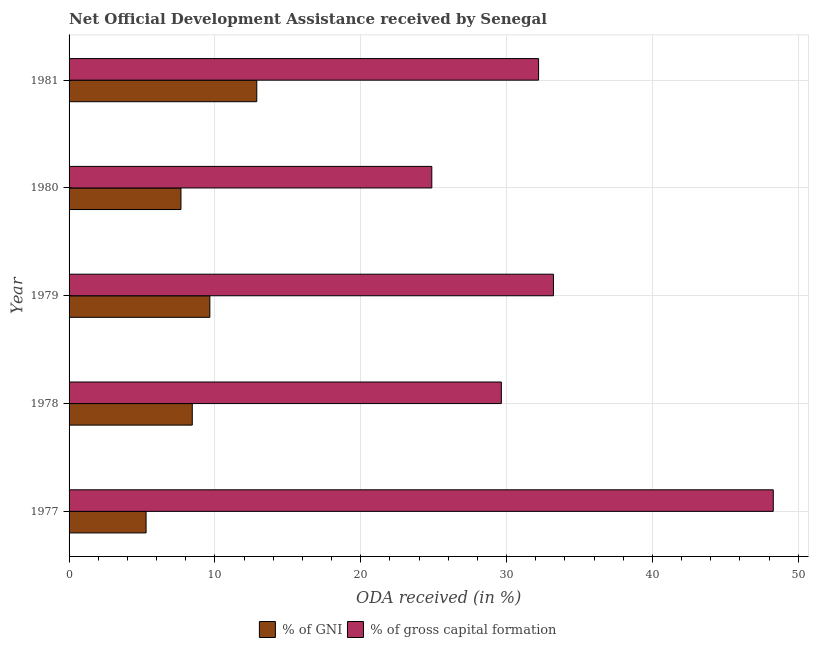How many different coloured bars are there?
Your answer should be compact. 2. Are the number of bars per tick equal to the number of legend labels?
Provide a short and direct response. Yes. Are the number of bars on each tick of the Y-axis equal?
Offer a very short reply. Yes. How many bars are there on the 1st tick from the top?
Your response must be concise. 2. What is the label of the 4th group of bars from the top?
Your answer should be very brief. 1978. What is the oda received as percentage of gni in 1978?
Your response must be concise. 8.45. Across all years, what is the maximum oda received as percentage of gni?
Your answer should be compact. 12.87. Across all years, what is the minimum oda received as percentage of gross capital formation?
Offer a very short reply. 24.87. What is the total oda received as percentage of gni in the graph?
Offer a terse response. 43.93. What is the difference between the oda received as percentage of gross capital formation in 1977 and that in 1981?
Ensure brevity in your answer.  16.09. What is the difference between the oda received as percentage of gross capital formation in 1981 and the oda received as percentage of gni in 1978?
Give a very brief answer. 23.75. What is the average oda received as percentage of gross capital formation per year?
Provide a short and direct response. 33.65. In the year 1979, what is the difference between the oda received as percentage of gross capital formation and oda received as percentage of gni?
Offer a very short reply. 23.56. What is the ratio of the oda received as percentage of gni in 1979 to that in 1980?
Keep it short and to the point. 1.26. What is the difference between the highest and the second highest oda received as percentage of gni?
Provide a succinct answer. 3.22. What is the difference between the highest and the lowest oda received as percentage of gni?
Provide a short and direct response. 7.59. What does the 2nd bar from the top in 1981 represents?
Provide a succinct answer. % of GNI. What does the 2nd bar from the bottom in 1978 represents?
Keep it short and to the point. % of gross capital formation. What is the difference between two consecutive major ticks on the X-axis?
Ensure brevity in your answer.  10. Are the values on the major ticks of X-axis written in scientific E-notation?
Your response must be concise. No. Does the graph contain any zero values?
Your response must be concise. No. Where does the legend appear in the graph?
Offer a very short reply. Bottom center. How are the legend labels stacked?
Your answer should be very brief. Horizontal. What is the title of the graph?
Your answer should be very brief. Net Official Development Assistance received by Senegal. Does "Nonresident" appear as one of the legend labels in the graph?
Your answer should be very brief. No. What is the label or title of the X-axis?
Your answer should be very brief. ODA received (in %). What is the label or title of the Y-axis?
Offer a terse response. Year. What is the ODA received (in %) in % of GNI in 1977?
Your answer should be compact. 5.28. What is the ODA received (in %) in % of gross capital formation in 1977?
Provide a succinct answer. 48.29. What is the ODA received (in %) in % of GNI in 1978?
Make the answer very short. 8.45. What is the ODA received (in %) in % of gross capital formation in 1978?
Give a very brief answer. 29.64. What is the ODA received (in %) in % of GNI in 1979?
Make the answer very short. 9.65. What is the ODA received (in %) of % of gross capital formation in 1979?
Ensure brevity in your answer.  33.22. What is the ODA received (in %) of % of GNI in 1980?
Ensure brevity in your answer.  7.67. What is the ODA received (in %) of % of gross capital formation in 1980?
Give a very brief answer. 24.87. What is the ODA received (in %) in % of GNI in 1981?
Your response must be concise. 12.87. What is the ODA received (in %) in % of gross capital formation in 1981?
Offer a very short reply. 32.2. Across all years, what is the maximum ODA received (in %) in % of GNI?
Provide a short and direct response. 12.87. Across all years, what is the maximum ODA received (in %) in % of gross capital formation?
Ensure brevity in your answer.  48.29. Across all years, what is the minimum ODA received (in %) of % of GNI?
Your response must be concise. 5.28. Across all years, what is the minimum ODA received (in %) of % of gross capital formation?
Offer a very short reply. 24.87. What is the total ODA received (in %) in % of GNI in the graph?
Your response must be concise. 43.93. What is the total ODA received (in %) in % of gross capital formation in the graph?
Provide a short and direct response. 168.22. What is the difference between the ODA received (in %) of % of GNI in 1977 and that in 1978?
Ensure brevity in your answer.  -3.17. What is the difference between the ODA received (in %) in % of gross capital formation in 1977 and that in 1978?
Ensure brevity in your answer.  18.65. What is the difference between the ODA received (in %) in % of GNI in 1977 and that in 1979?
Your answer should be very brief. -4.37. What is the difference between the ODA received (in %) in % of gross capital formation in 1977 and that in 1979?
Provide a short and direct response. 15.07. What is the difference between the ODA received (in %) in % of GNI in 1977 and that in 1980?
Provide a short and direct response. -2.39. What is the difference between the ODA received (in %) of % of gross capital formation in 1977 and that in 1980?
Give a very brief answer. 23.42. What is the difference between the ODA received (in %) of % of GNI in 1977 and that in 1981?
Make the answer very short. -7.59. What is the difference between the ODA received (in %) in % of gross capital formation in 1977 and that in 1981?
Keep it short and to the point. 16.1. What is the difference between the ODA received (in %) of % of GNI in 1978 and that in 1979?
Your answer should be very brief. -1.21. What is the difference between the ODA received (in %) in % of gross capital formation in 1978 and that in 1979?
Ensure brevity in your answer.  -3.57. What is the difference between the ODA received (in %) of % of GNI in 1978 and that in 1980?
Provide a succinct answer. 0.78. What is the difference between the ODA received (in %) in % of gross capital formation in 1978 and that in 1980?
Your answer should be very brief. 4.77. What is the difference between the ODA received (in %) of % of GNI in 1978 and that in 1981?
Offer a terse response. -4.42. What is the difference between the ODA received (in %) in % of gross capital formation in 1978 and that in 1981?
Your answer should be compact. -2.55. What is the difference between the ODA received (in %) in % of GNI in 1979 and that in 1980?
Offer a very short reply. 1.98. What is the difference between the ODA received (in %) in % of gross capital formation in 1979 and that in 1980?
Your answer should be compact. 8.34. What is the difference between the ODA received (in %) of % of GNI in 1979 and that in 1981?
Provide a short and direct response. -3.22. What is the difference between the ODA received (in %) in % of gross capital formation in 1979 and that in 1981?
Offer a terse response. 1.02. What is the difference between the ODA received (in %) of % of GNI in 1980 and that in 1981?
Provide a short and direct response. -5.2. What is the difference between the ODA received (in %) in % of gross capital formation in 1980 and that in 1981?
Your answer should be very brief. -7.32. What is the difference between the ODA received (in %) in % of GNI in 1977 and the ODA received (in %) in % of gross capital formation in 1978?
Provide a succinct answer. -24.36. What is the difference between the ODA received (in %) in % of GNI in 1977 and the ODA received (in %) in % of gross capital formation in 1979?
Make the answer very short. -27.94. What is the difference between the ODA received (in %) of % of GNI in 1977 and the ODA received (in %) of % of gross capital formation in 1980?
Offer a terse response. -19.59. What is the difference between the ODA received (in %) of % of GNI in 1977 and the ODA received (in %) of % of gross capital formation in 1981?
Your answer should be compact. -26.91. What is the difference between the ODA received (in %) of % of GNI in 1978 and the ODA received (in %) of % of gross capital formation in 1979?
Your answer should be very brief. -24.77. What is the difference between the ODA received (in %) in % of GNI in 1978 and the ODA received (in %) in % of gross capital formation in 1980?
Keep it short and to the point. -16.43. What is the difference between the ODA received (in %) of % of GNI in 1978 and the ODA received (in %) of % of gross capital formation in 1981?
Your answer should be very brief. -23.75. What is the difference between the ODA received (in %) in % of GNI in 1979 and the ODA received (in %) in % of gross capital formation in 1980?
Provide a succinct answer. -15.22. What is the difference between the ODA received (in %) of % of GNI in 1979 and the ODA received (in %) of % of gross capital formation in 1981?
Give a very brief answer. -22.54. What is the difference between the ODA received (in %) in % of GNI in 1980 and the ODA received (in %) in % of gross capital formation in 1981?
Offer a very short reply. -24.52. What is the average ODA received (in %) of % of GNI per year?
Keep it short and to the point. 8.79. What is the average ODA received (in %) in % of gross capital formation per year?
Offer a terse response. 33.64. In the year 1977, what is the difference between the ODA received (in %) in % of GNI and ODA received (in %) in % of gross capital formation?
Make the answer very short. -43.01. In the year 1978, what is the difference between the ODA received (in %) in % of GNI and ODA received (in %) in % of gross capital formation?
Your answer should be compact. -21.2. In the year 1979, what is the difference between the ODA received (in %) in % of GNI and ODA received (in %) in % of gross capital formation?
Offer a very short reply. -23.56. In the year 1980, what is the difference between the ODA received (in %) of % of GNI and ODA received (in %) of % of gross capital formation?
Make the answer very short. -17.2. In the year 1981, what is the difference between the ODA received (in %) in % of GNI and ODA received (in %) in % of gross capital formation?
Keep it short and to the point. -19.32. What is the ratio of the ODA received (in %) of % of GNI in 1977 to that in 1978?
Your answer should be very brief. 0.62. What is the ratio of the ODA received (in %) in % of gross capital formation in 1977 to that in 1978?
Your answer should be compact. 1.63. What is the ratio of the ODA received (in %) of % of GNI in 1977 to that in 1979?
Keep it short and to the point. 0.55. What is the ratio of the ODA received (in %) in % of gross capital formation in 1977 to that in 1979?
Your response must be concise. 1.45. What is the ratio of the ODA received (in %) of % of GNI in 1977 to that in 1980?
Your answer should be very brief. 0.69. What is the ratio of the ODA received (in %) of % of gross capital formation in 1977 to that in 1980?
Your response must be concise. 1.94. What is the ratio of the ODA received (in %) in % of GNI in 1977 to that in 1981?
Keep it short and to the point. 0.41. What is the ratio of the ODA received (in %) of % of gross capital formation in 1977 to that in 1981?
Make the answer very short. 1.5. What is the ratio of the ODA received (in %) in % of GNI in 1978 to that in 1979?
Your response must be concise. 0.88. What is the ratio of the ODA received (in %) of % of gross capital formation in 1978 to that in 1979?
Your answer should be very brief. 0.89. What is the ratio of the ODA received (in %) in % of GNI in 1978 to that in 1980?
Your answer should be very brief. 1.1. What is the ratio of the ODA received (in %) in % of gross capital formation in 1978 to that in 1980?
Give a very brief answer. 1.19. What is the ratio of the ODA received (in %) of % of GNI in 1978 to that in 1981?
Keep it short and to the point. 0.66. What is the ratio of the ODA received (in %) in % of gross capital formation in 1978 to that in 1981?
Give a very brief answer. 0.92. What is the ratio of the ODA received (in %) in % of GNI in 1979 to that in 1980?
Provide a short and direct response. 1.26. What is the ratio of the ODA received (in %) in % of gross capital formation in 1979 to that in 1980?
Give a very brief answer. 1.34. What is the ratio of the ODA received (in %) of % of gross capital formation in 1979 to that in 1981?
Your answer should be compact. 1.03. What is the ratio of the ODA received (in %) of % of GNI in 1980 to that in 1981?
Keep it short and to the point. 0.6. What is the ratio of the ODA received (in %) of % of gross capital formation in 1980 to that in 1981?
Your response must be concise. 0.77. What is the difference between the highest and the second highest ODA received (in %) in % of GNI?
Keep it short and to the point. 3.22. What is the difference between the highest and the second highest ODA received (in %) of % of gross capital formation?
Make the answer very short. 15.07. What is the difference between the highest and the lowest ODA received (in %) of % of GNI?
Provide a short and direct response. 7.59. What is the difference between the highest and the lowest ODA received (in %) of % of gross capital formation?
Provide a succinct answer. 23.42. 